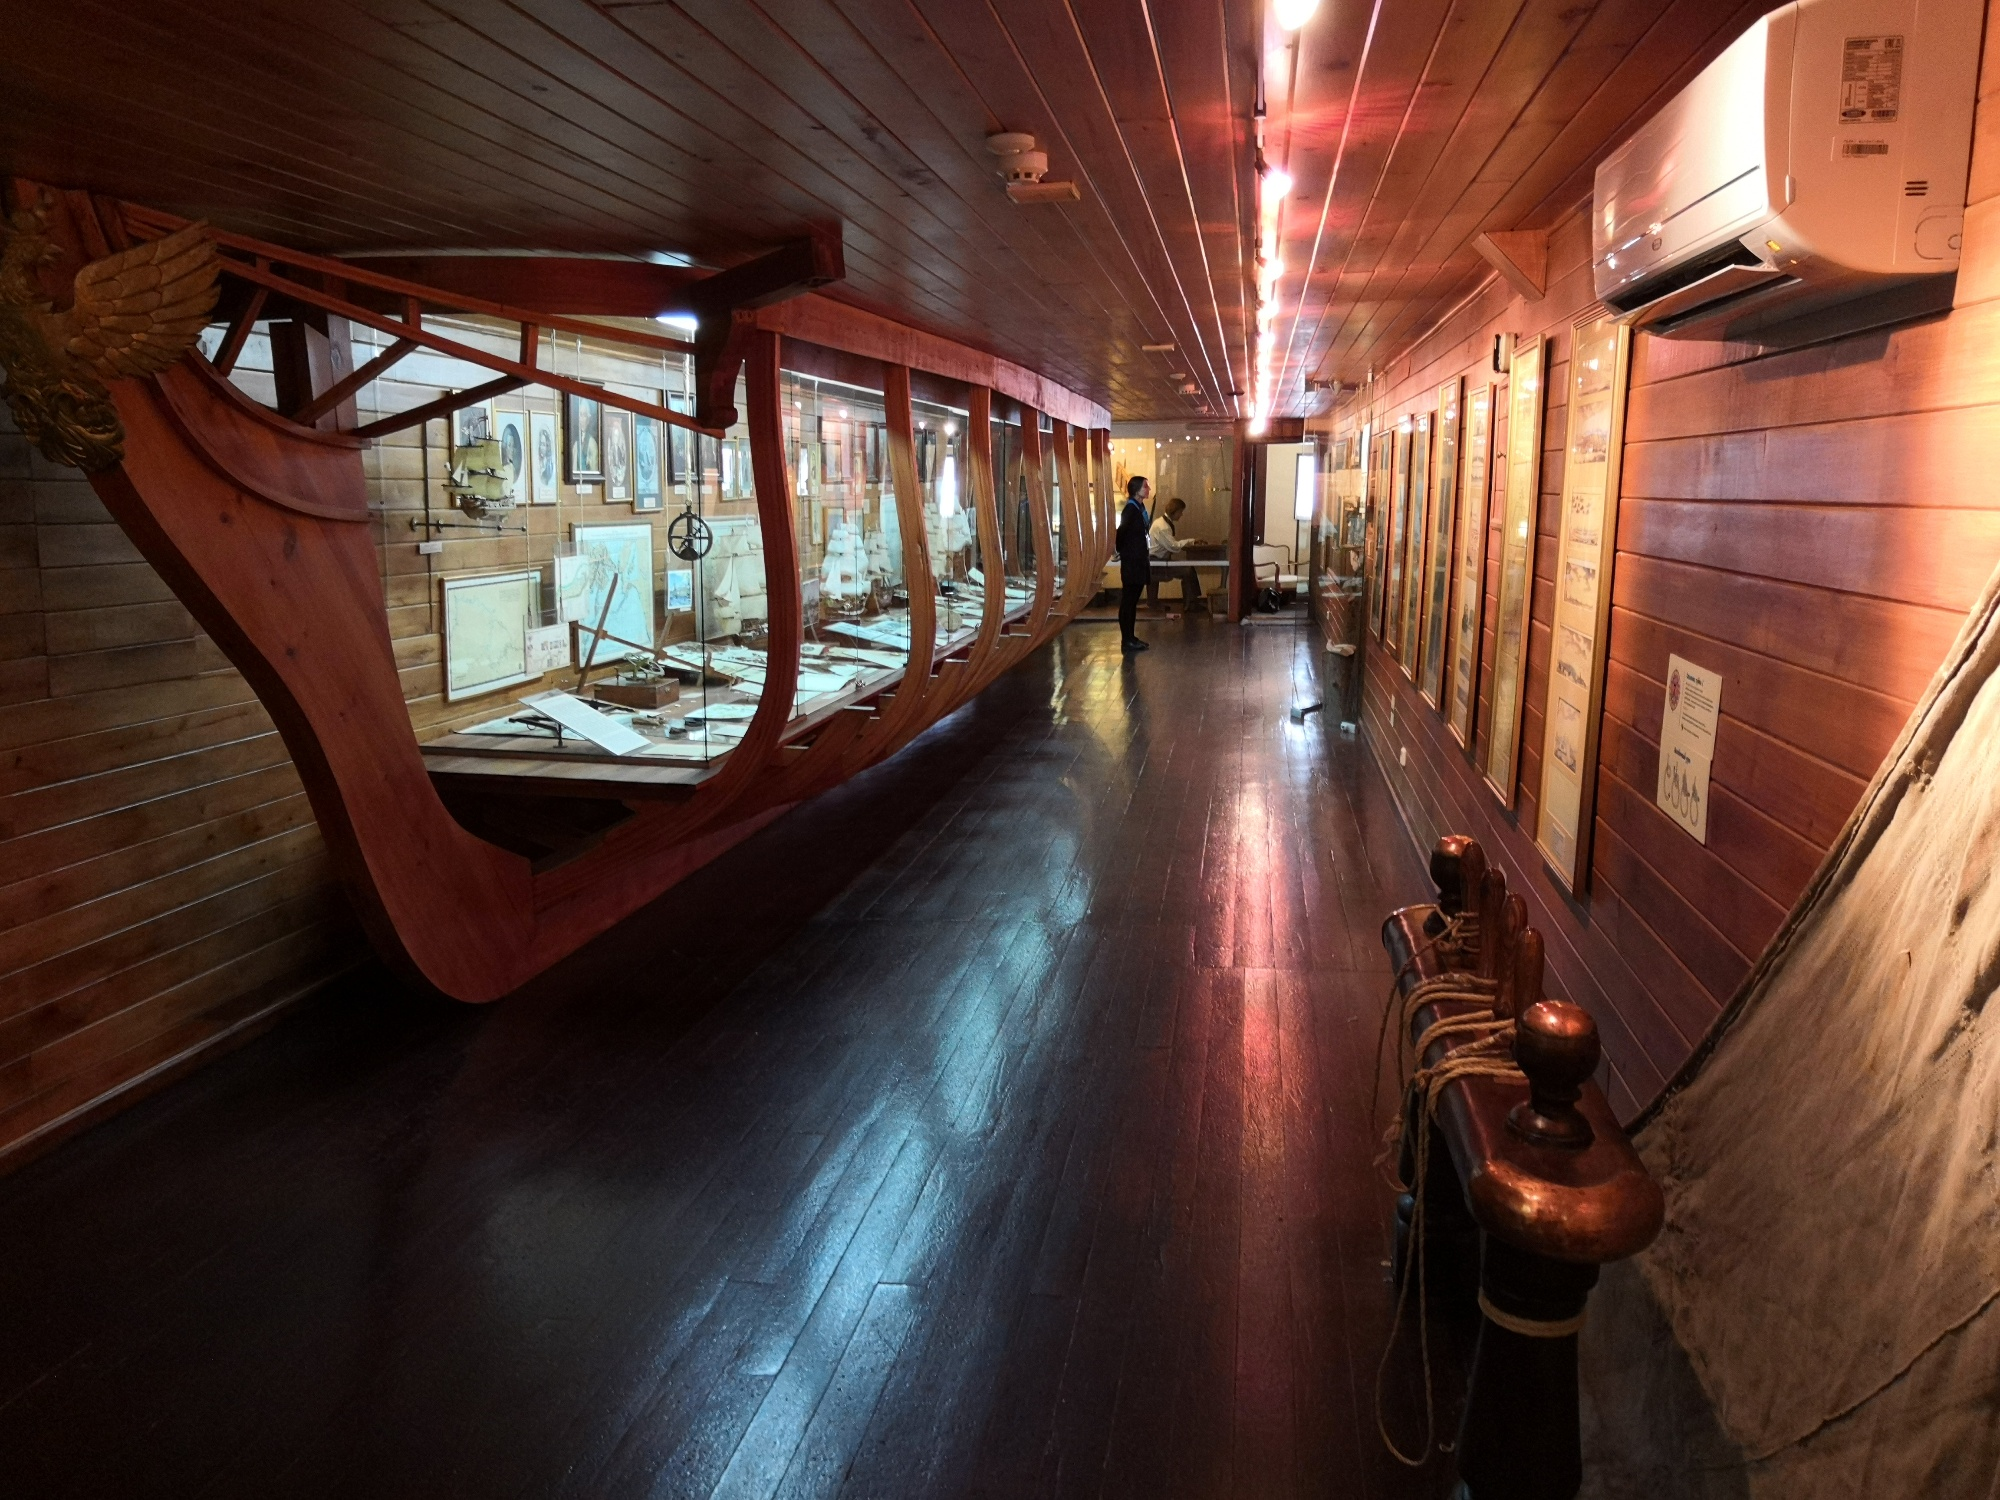What unusual incident do you think might have happened here? Imagine an unusual incident where, during a quiet afternoon at the museum, the lights flicker and a strange glow surrounds the ship's bow exhibit. Suddenly, a spectral figure dressed in 15th-century seafarer's attire appears, startling the visitors. This ghostly sailor wanders through the room, seemingly drawn to the artifacts on display. He pauses at a map, his transparent finger tracing the routes he once sailed. Museum-goers watch in awe and trepidation as the apparition relives moments of his past voyages before vanishing as abruptly as he appeared, leaving a whisper of sea-salt air and a deeper connection to the legacy of oceanic exploration. 